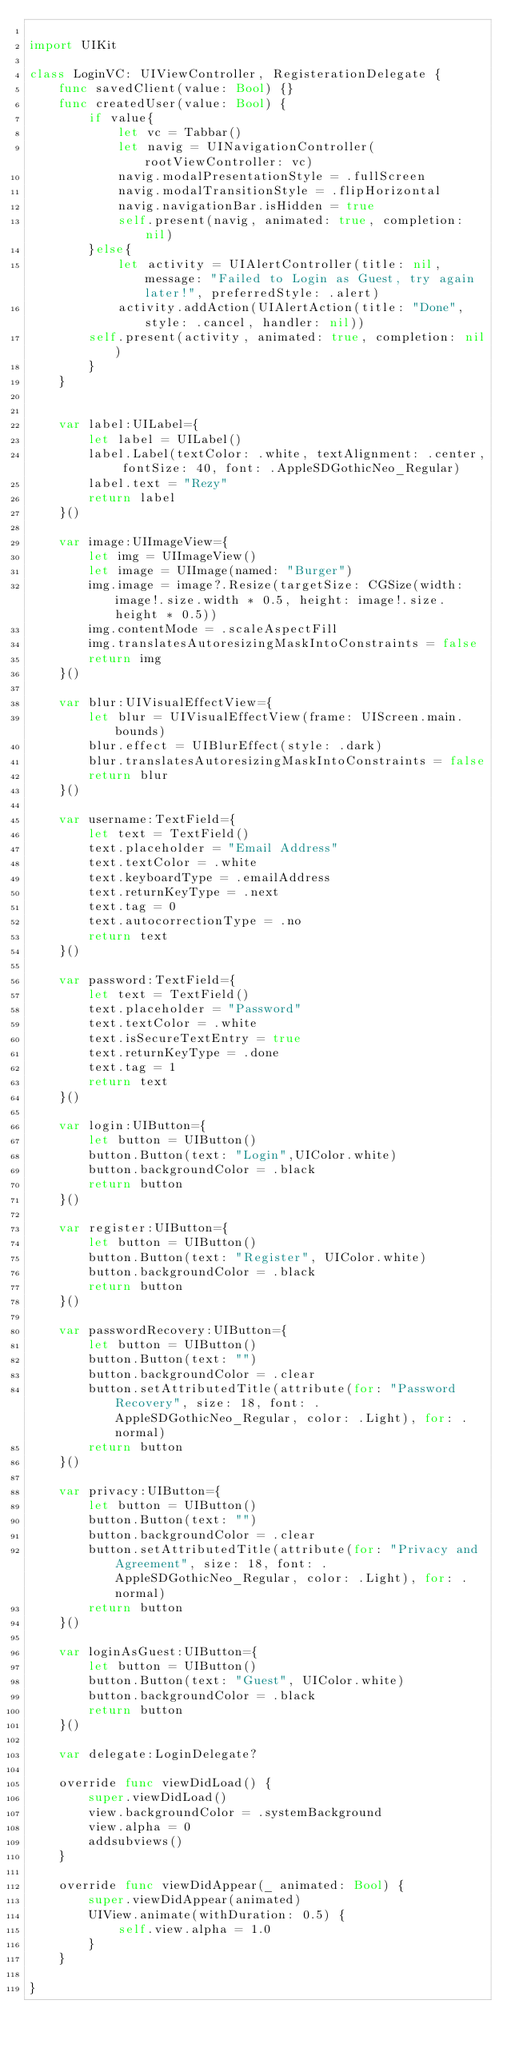Convert code to text. <code><loc_0><loc_0><loc_500><loc_500><_Swift_>
import UIKit

class LoginVC: UIViewController, RegisterationDelegate {
    func savedClient(value: Bool) {}
    func createdUser(value: Bool) {
        if value{
            let vc = Tabbar()
            let navig = UINavigationController(rootViewController: vc)
            navig.modalPresentationStyle = .fullScreen
            navig.modalTransitionStyle = .flipHorizontal
            navig.navigationBar.isHidden = true
            self.present(navig, animated: true, completion: nil)
        }else{
            let activity = UIAlertController(title: nil, message: "Failed to Login as Guest, try again later!", preferredStyle: .alert)
            activity.addAction(UIAlertAction(title: "Done", style: .cancel, handler: nil))
        self.present(activity, animated: true, completion: nil)
        }
    }
     
    
    var label:UILabel={
        let label = UILabel()
        label.Label(textColor: .white, textAlignment: .center, fontSize: 40, font: .AppleSDGothicNeo_Regular)
        label.text = "Rezy"
        return label
    }()

    var image:UIImageView={
        let img = UIImageView()
        let image = UIImage(named: "Burger")
        img.image = image?.Resize(targetSize: CGSize(width: image!.size.width * 0.5, height: image!.size.height * 0.5))
        img.contentMode = .scaleAspectFill
        img.translatesAutoresizingMaskIntoConstraints = false
        return img
    }()
    
    var blur:UIVisualEffectView={
        let blur = UIVisualEffectView(frame: UIScreen.main.bounds)
        blur.effect = UIBlurEffect(style: .dark)
        blur.translatesAutoresizingMaskIntoConstraints = false
        return blur
    }()
    
    var username:TextField={
        let text = TextField()
        text.placeholder = "Email Address"
        text.textColor = .white
        text.keyboardType = .emailAddress
        text.returnKeyType = .next
        text.tag = 0
        text.autocorrectionType = .no
        return text
    }()
    
    var password:TextField={
        let text = TextField()
        text.placeholder = "Password"
        text.textColor = .white
        text.isSecureTextEntry = true
        text.returnKeyType = .done
        text.tag = 1
        return text
    }()
    
    var login:UIButton={
        let button = UIButton()
        button.Button(text: "Login",UIColor.white)
        button.backgroundColor = .black
        return button
    }()
    
    var register:UIButton={
        let button = UIButton()
        button.Button(text: "Register", UIColor.white)
        button.backgroundColor = .black
        return button
    }()
        
    var passwordRecovery:UIButton={
        let button = UIButton()
        button.Button(text: "")
        button.backgroundColor = .clear
        button.setAttributedTitle(attribute(for: "Password Recovery", size: 18, font: .AppleSDGothicNeo_Regular, color: .Light), for: .normal)
        return button
    }()
    
    var privacy:UIButton={
        let button = UIButton()
        button.Button(text: "")
        button.backgroundColor = .clear
        button.setAttributedTitle(attribute(for: "Privacy and Agreement", size: 18, font: .AppleSDGothicNeo_Regular, color: .Light), for: .normal)
        return button
    }()
    
    var loginAsGuest:UIButton={
        let button = UIButton()
        button.Button(text: "Guest", UIColor.white)
        button.backgroundColor = .black
        return button
    }()
    
    var delegate:LoginDelegate?
    
    override func viewDidLoad() {
        super.viewDidLoad()
        view.backgroundColor = .systemBackground
        view.alpha = 0
        addsubviews()
    }
    
    override func viewDidAppear(_ animated: Bool) {
        super.viewDidAppear(animated)
        UIView.animate(withDuration: 0.5) {
            self.view.alpha = 1.0
        }
    }

}
</code> 